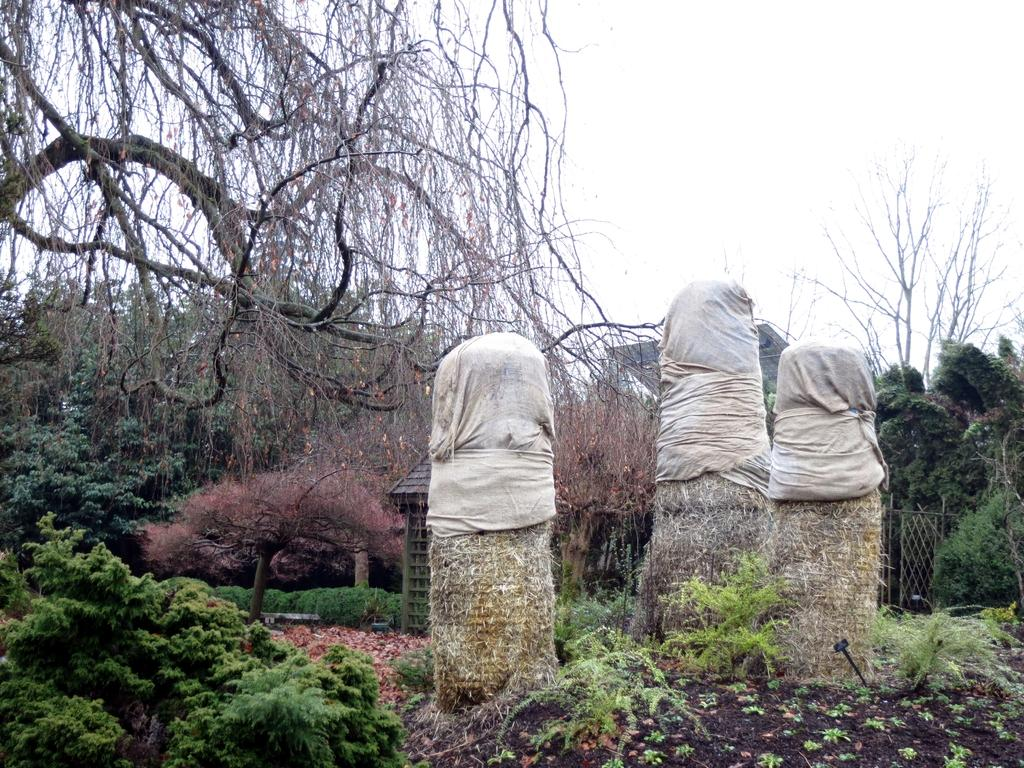What is on the ground in the image? There are objects on the ground in the image. What can be seen in the background of the image? There are many trees and plants in the image. Is there any structure visible in the image? Yes, there is a small hut behind one of the objects in the image. How many bikes are present in the image? There is no bike present in the image. What type of science is being conducted in the image? There is no indication of any scientific activity in the image. 